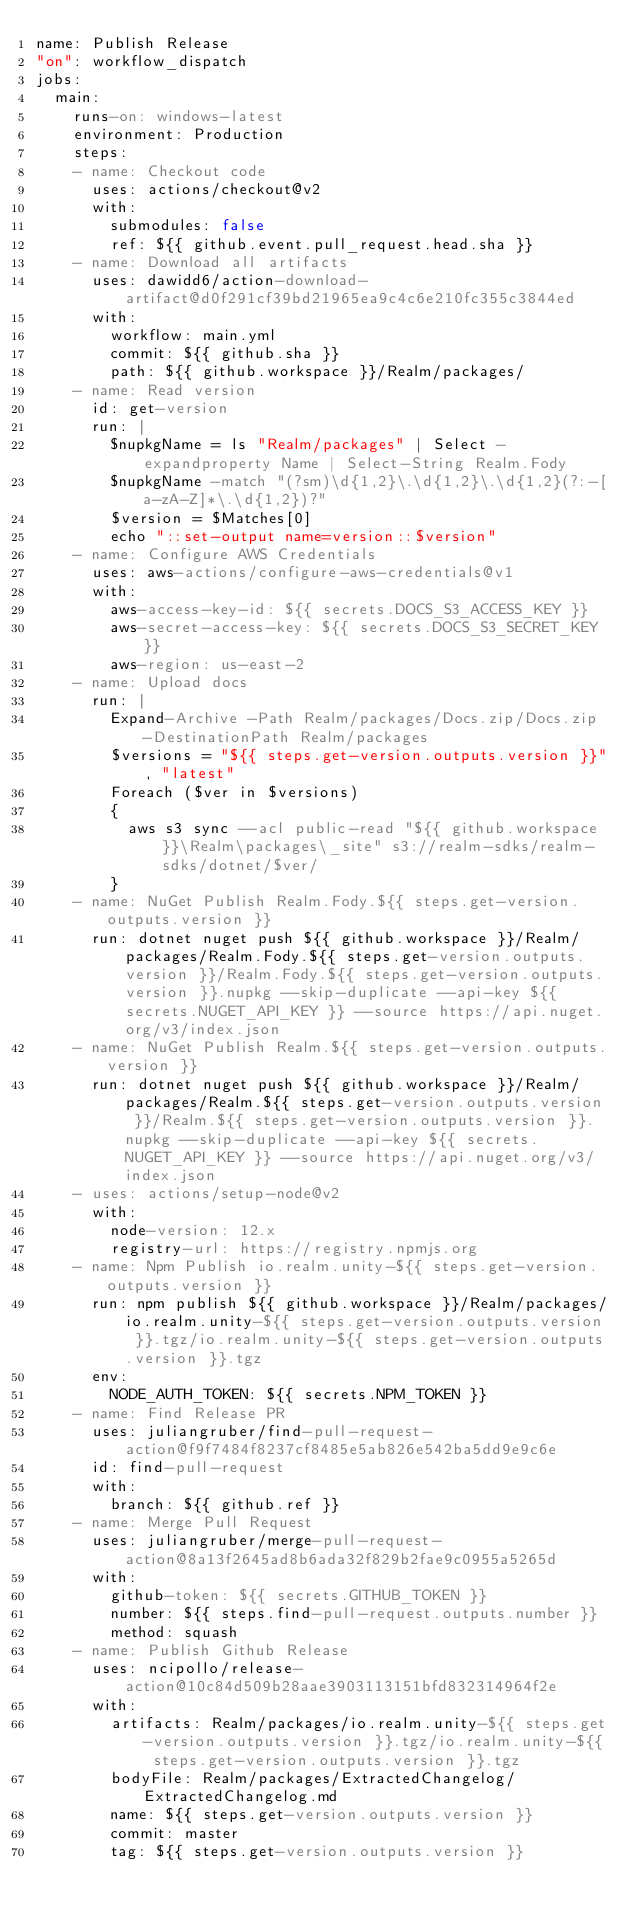Convert code to text. <code><loc_0><loc_0><loc_500><loc_500><_YAML_>name: Publish Release
"on": workflow_dispatch
jobs:
  main:
    runs-on: windows-latest
    environment: Production
    steps:
    - name: Checkout code
      uses: actions/checkout@v2
      with:
        submodules: false
        ref: ${{ github.event.pull_request.head.sha }}
    - name: Download all artifacts
      uses: dawidd6/action-download-artifact@d0f291cf39bd21965ea9c4c6e210fc355c3844ed
      with:
        workflow: main.yml
        commit: ${{ github.sha }}
        path: ${{ github.workspace }}/Realm/packages/
    - name: Read version
      id: get-version
      run: |
        $nupkgName = ls "Realm/packages" | Select -expandproperty Name | Select-String Realm.Fody
        $nupkgName -match "(?sm)\d{1,2}\.\d{1,2}\.\d{1,2}(?:-[a-zA-Z]*\.\d{1,2})?"
        $version = $Matches[0]
        echo "::set-output name=version::$version"
    - name: Configure AWS Credentials
      uses: aws-actions/configure-aws-credentials@v1
      with:
        aws-access-key-id: ${{ secrets.DOCS_S3_ACCESS_KEY }}
        aws-secret-access-key: ${{ secrets.DOCS_S3_SECRET_KEY }}
        aws-region: us-east-2
    - name: Upload docs
      run: |
        Expand-Archive -Path Realm/packages/Docs.zip/Docs.zip -DestinationPath Realm/packages
        $versions = "${{ steps.get-version.outputs.version }}", "latest"
        Foreach ($ver in $versions)
        {
          aws s3 sync --acl public-read "${{ github.workspace }}\Realm\packages\_site" s3://realm-sdks/realm-sdks/dotnet/$ver/
        }
    - name: NuGet Publish Realm.Fody.${{ steps.get-version.outputs.version }}
      run: dotnet nuget push ${{ github.workspace }}/Realm/packages/Realm.Fody.${{ steps.get-version.outputs.version }}/Realm.Fody.${{ steps.get-version.outputs.version }}.nupkg --skip-duplicate --api-key ${{ secrets.NUGET_API_KEY }} --source https://api.nuget.org/v3/index.json
    - name: NuGet Publish Realm.${{ steps.get-version.outputs.version }}
      run: dotnet nuget push ${{ github.workspace }}/Realm/packages/Realm.${{ steps.get-version.outputs.version }}/Realm.${{ steps.get-version.outputs.version }}.nupkg --skip-duplicate --api-key ${{ secrets.NUGET_API_KEY }} --source https://api.nuget.org/v3/index.json
    - uses: actions/setup-node@v2
      with:
        node-version: 12.x
        registry-url: https://registry.npmjs.org
    - name: Npm Publish io.realm.unity-${{ steps.get-version.outputs.version }}
      run: npm publish ${{ github.workspace }}/Realm/packages/io.realm.unity-${{ steps.get-version.outputs.version }}.tgz/io.realm.unity-${{ steps.get-version.outputs.version }}.tgz
      env:
        NODE_AUTH_TOKEN: ${{ secrets.NPM_TOKEN }}
    - name: Find Release PR
      uses: juliangruber/find-pull-request-action@f9f7484f8237cf8485e5ab826e542ba5dd9e9c6e
      id: find-pull-request
      with:
        branch: ${{ github.ref }}
    - name: Merge Pull Request
      uses: juliangruber/merge-pull-request-action@8a13f2645ad8b6ada32f829b2fae9c0955a5265d
      with:
        github-token: ${{ secrets.GITHUB_TOKEN }}
        number: ${{ steps.find-pull-request.outputs.number }}
        method: squash
    - name: Publish Github Release
      uses: ncipollo/release-action@10c84d509b28aae3903113151bfd832314964f2e
      with:
        artifacts: Realm/packages/io.realm.unity-${{ steps.get-version.outputs.version }}.tgz/io.realm.unity-${{ steps.get-version.outputs.version }}.tgz
        bodyFile: Realm/packages/ExtractedChangelog/ExtractedChangelog.md
        name: ${{ steps.get-version.outputs.version }}
        commit: master
        tag: ${{ steps.get-version.outputs.version }}</code> 